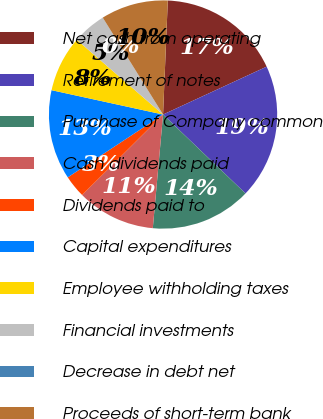Convert chart. <chart><loc_0><loc_0><loc_500><loc_500><pie_chart><fcel>Net cash from operating<fcel>Retirement of notes<fcel>Purchase of Company common<fcel>Cash dividends paid<fcel>Dividends paid to<fcel>Capital expenditures<fcel>Employee withholding taxes<fcel>Financial investments<fcel>Decrease in debt net<fcel>Proceeds of short-term bank<nl><fcel>17.45%<fcel>19.04%<fcel>14.28%<fcel>11.11%<fcel>3.18%<fcel>12.7%<fcel>7.94%<fcel>4.77%<fcel>0.01%<fcel>9.52%<nl></chart> 